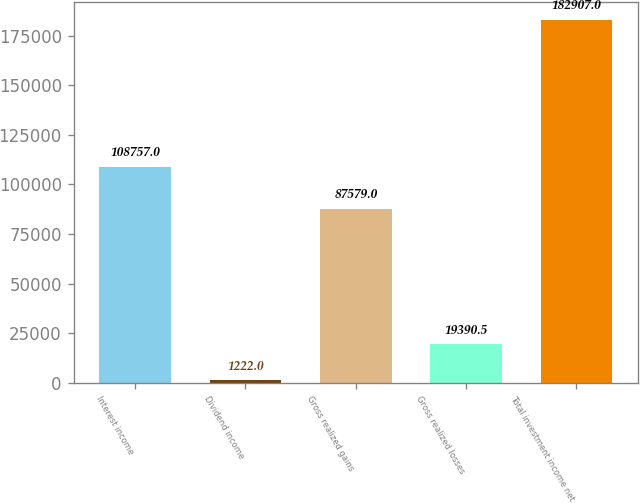<chart> <loc_0><loc_0><loc_500><loc_500><bar_chart><fcel>Interest income<fcel>Dividend income<fcel>Gross realized gains<fcel>Gross realized losses<fcel>Total investment income net<nl><fcel>108757<fcel>1222<fcel>87579<fcel>19390.5<fcel>182907<nl></chart> 